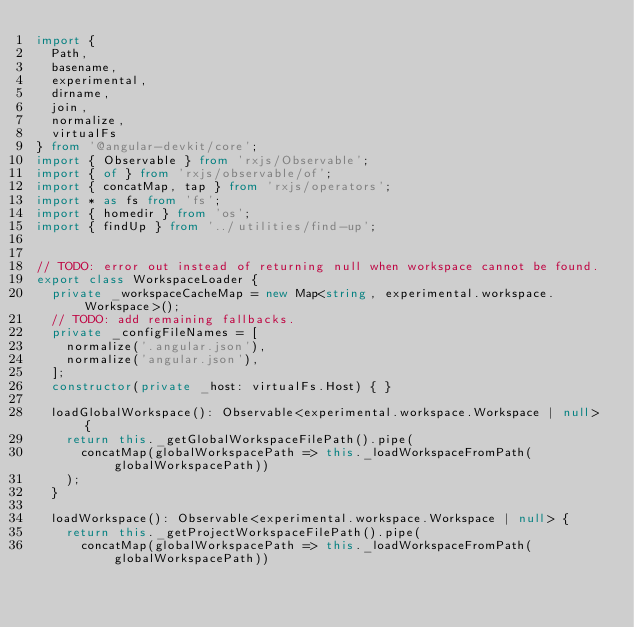<code> <loc_0><loc_0><loc_500><loc_500><_TypeScript_>import {
  Path,
  basename,
  experimental,
  dirname,
  join,
  normalize,
  virtualFs
} from '@angular-devkit/core';
import { Observable } from 'rxjs/Observable';
import { of } from 'rxjs/observable/of';
import { concatMap, tap } from 'rxjs/operators';
import * as fs from 'fs';
import { homedir } from 'os';
import { findUp } from '../utilities/find-up';


// TODO: error out instead of returning null when workspace cannot be found.
export class WorkspaceLoader {
  private _workspaceCacheMap = new Map<string, experimental.workspace.Workspace>();
  // TODO: add remaining fallbacks.
  private _configFileNames = [
    normalize('.angular.json'),
    normalize('angular.json'),
  ];
  constructor(private _host: virtualFs.Host) { }

  loadGlobalWorkspace(): Observable<experimental.workspace.Workspace | null> {
    return this._getGlobalWorkspaceFilePath().pipe(
      concatMap(globalWorkspacePath => this._loadWorkspaceFromPath(globalWorkspacePath))
    );
  }

  loadWorkspace(): Observable<experimental.workspace.Workspace | null> {
    return this._getProjectWorkspaceFilePath().pipe(
      concatMap(globalWorkspacePath => this._loadWorkspaceFromPath(globalWorkspacePath))</code> 